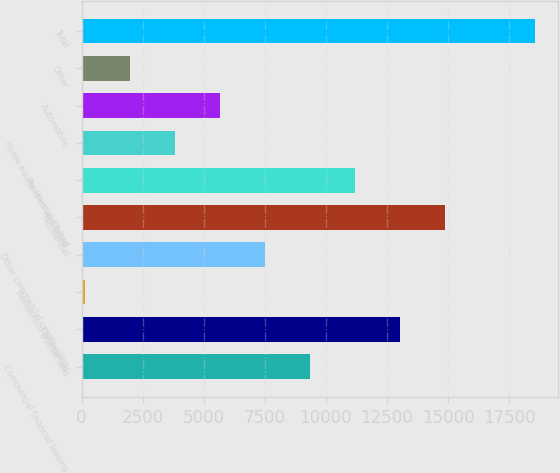Convert chart to OTSL. <chart><loc_0><loc_0><loc_500><loc_500><bar_chart><fcel>Commercial financial leasing<fcel>Commercial<fcel>Residential builder and<fcel>Other commercial construction<fcel>Residential<fcel>Residential-limited<fcel>Home equity lines and loans<fcel>Automobile<fcel>Other<fcel>Total<nl><fcel>9357.5<fcel>13043.7<fcel>142<fcel>7514.4<fcel>14886.8<fcel>11200.6<fcel>3828.2<fcel>5671.3<fcel>1985.1<fcel>18573<nl></chart> 